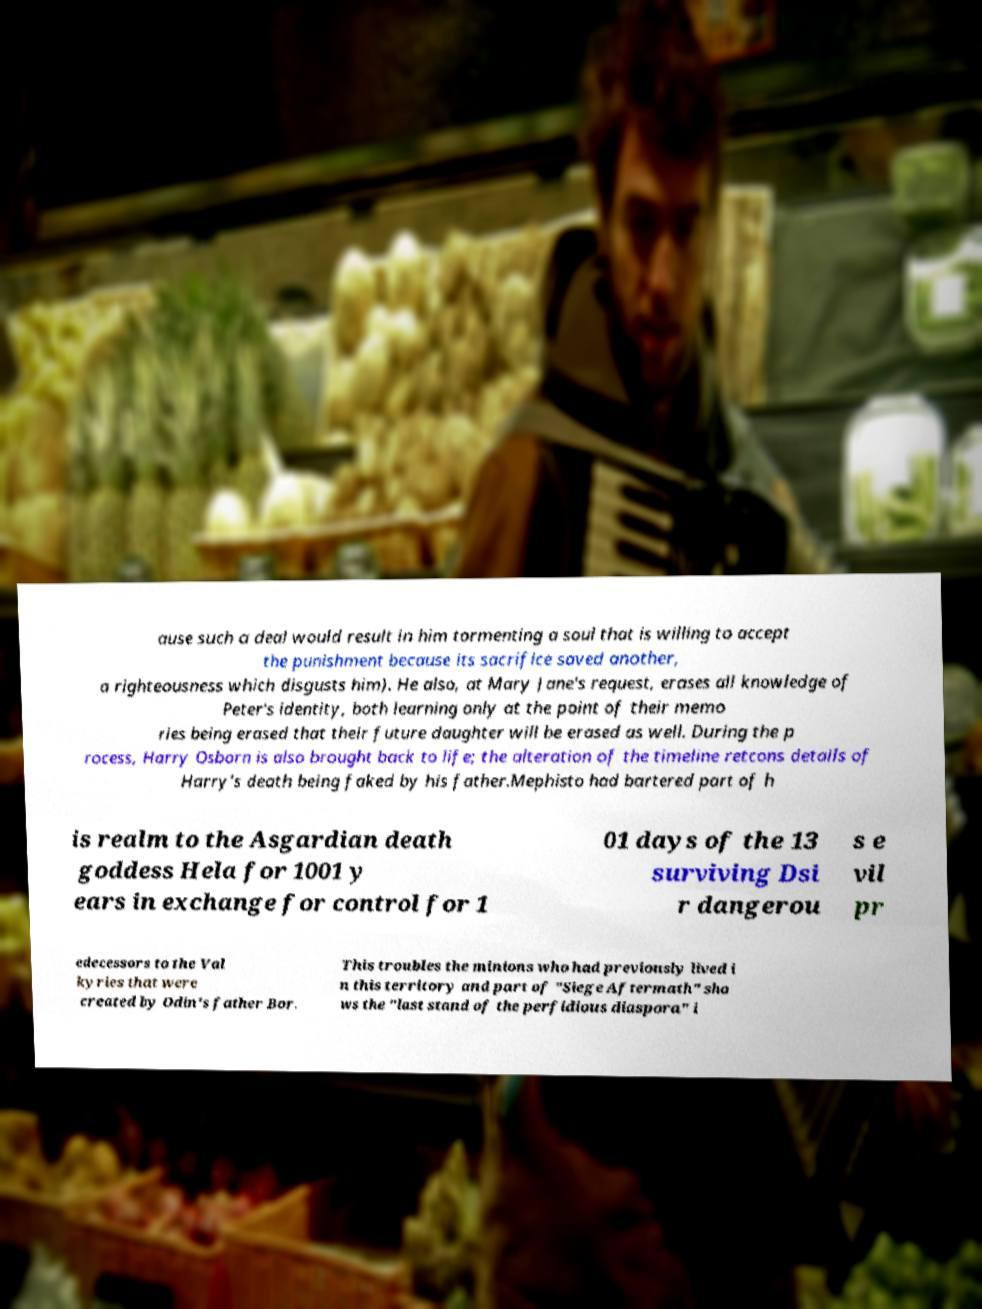There's text embedded in this image that I need extracted. Can you transcribe it verbatim? ause such a deal would result in him tormenting a soul that is willing to accept the punishment because its sacrifice saved another, a righteousness which disgusts him). He also, at Mary Jane's request, erases all knowledge of Peter's identity, both learning only at the point of their memo ries being erased that their future daughter will be erased as well. During the p rocess, Harry Osborn is also brought back to life; the alteration of the timeline retcons details of Harry's death being faked by his father.Mephisto had bartered part of h is realm to the Asgardian death goddess Hela for 1001 y ears in exchange for control for 1 01 days of the 13 surviving Dsi r dangerou s e vil pr edecessors to the Val kyries that were created by Odin's father Bor. This troubles the minions who had previously lived i n this territory and part of "Siege Aftermath" sho ws the "last stand of the perfidious diaspora" i 